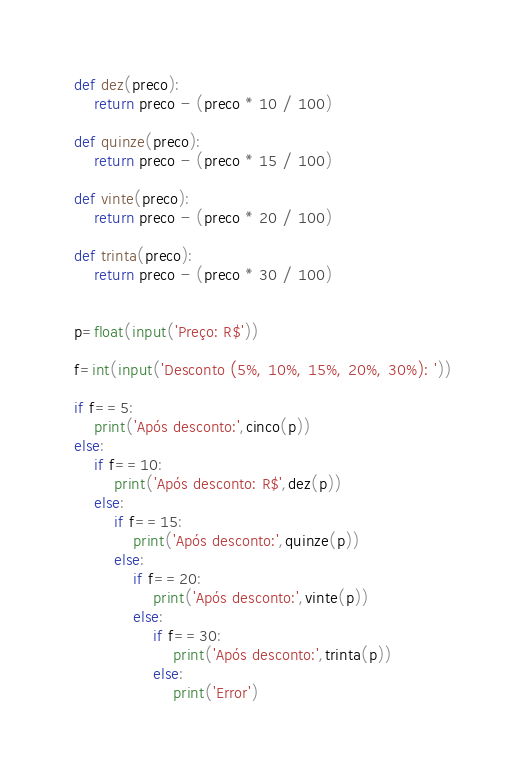Convert code to text. <code><loc_0><loc_0><loc_500><loc_500><_Python_>
def dez(preco):
    return preco - (preco * 10 / 100)

def quinze(preco):
    return preco - (preco * 15 / 100)

def vinte(preco):
    return preco - (preco * 20 / 100)

def trinta(preco):
    return preco - (preco * 30 / 100)


p=float(input('Preço: R$'))

f=int(input('Desconto (5%, 10%, 15%, 20%, 30%): '))

if f==5:
    print('Após desconto:',cinco(p))
else:
    if f==10:
        print('Após desconto: R$',dez(p))
    else:
        if f==15:
            print('Após desconto:',quinze(p))
        else:
            if f==20:
                print('Após desconto:',vinte(p))
            else:
                if f==30:
                    print('Após desconto:',trinta(p))
                else:
                    print('Error')
</code> 